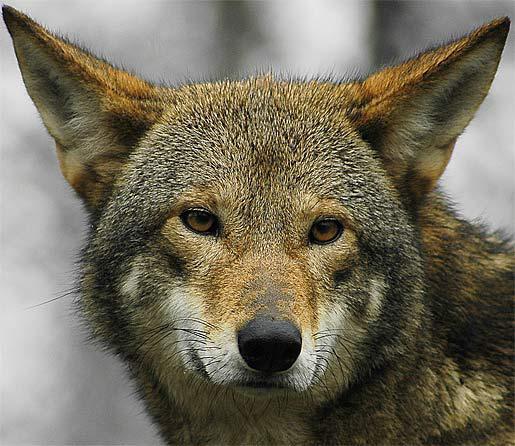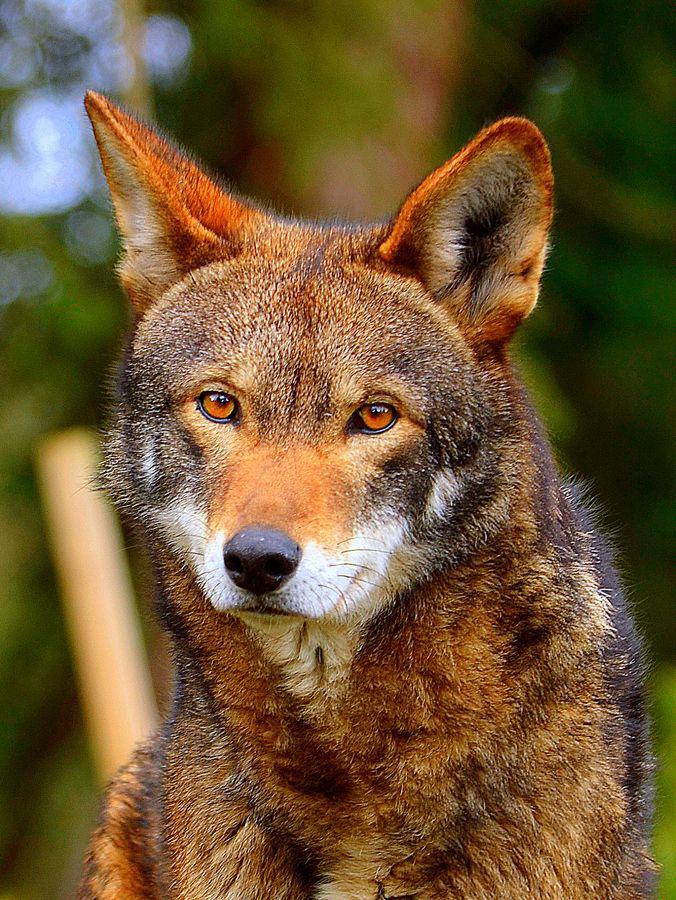The first image is the image on the left, the second image is the image on the right. Considering the images on both sides, is "An image shows a wolf with a dusting of snow on its fur." valid? Answer yes or no. No. The first image is the image on the left, the second image is the image on the right. For the images displayed, is the sentence "The wild dog in one of the images is lying down." factually correct? Answer yes or no. No. 